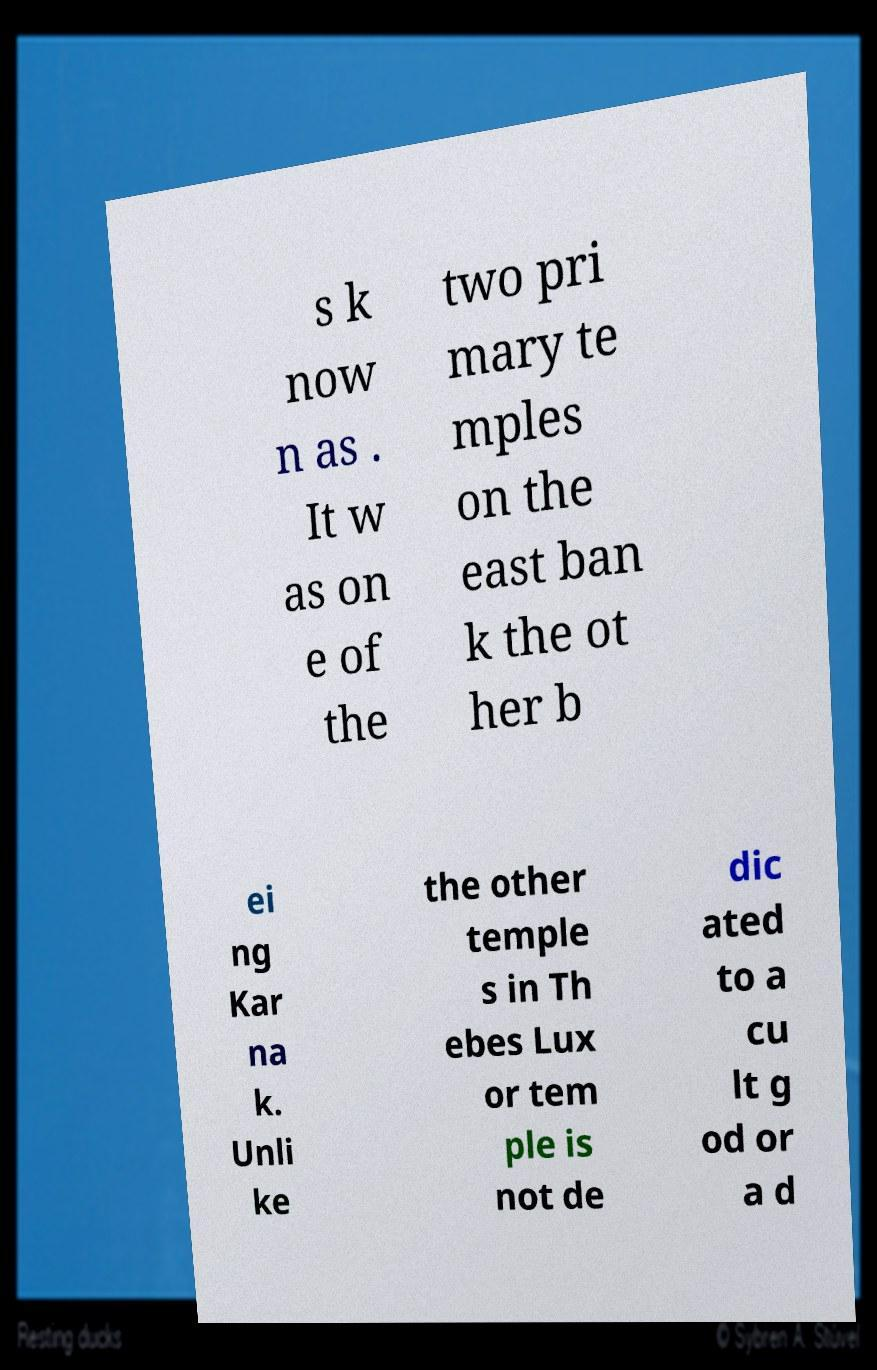Please identify and transcribe the text found in this image. s k now n as . It w as on e of the two pri mary te mples on the east ban k the ot her b ei ng Kar na k. Unli ke the other temple s in Th ebes Lux or tem ple is not de dic ated to a cu lt g od or a d 